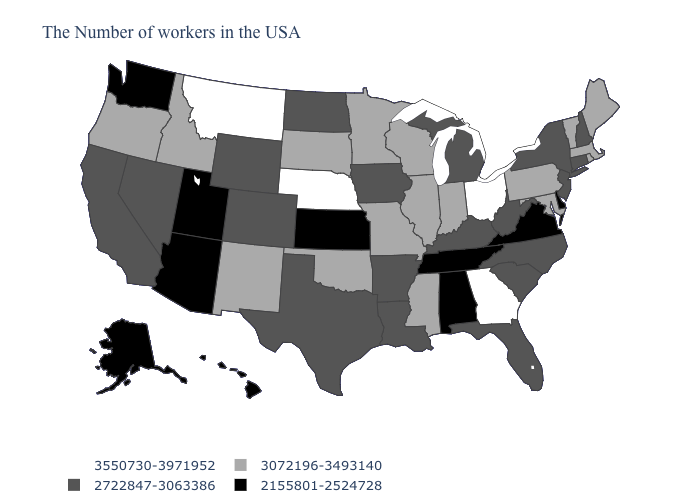What is the value of West Virginia?
Give a very brief answer. 2722847-3063386. What is the highest value in the USA?
Answer briefly. 3550730-3971952. Does Florida have a higher value than Kansas?
Quick response, please. Yes. Does Oregon have a higher value than West Virginia?
Short answer required. Yes. How many symbols are there in the legend?
Write a very short answer. 4. Among the states that border Florida , does Alabama have the highest value?
Write a very short answer. No. What is the highest value in states that border Minnesota?
Concise answer only. 3072196-3493140. What is the highest value in the MidWest ?
Quick response, please. 3550730-3971952. Does Pennsylvania have the same value as Maine?
Quick response, please. Yes. Does the first symbol in the legend represent the smallest category?
Answer briefly. No. Among the states that border Montana , which have the lowest value?
Write a very short answer. North Dakota, Wyoming. Which states have the lowest value in the West?
Be succinct. Utah, Arizona, Washington, Alaska, Hawaii. Which states hav the highest value in the Northeast?
Quick response, please. Maine, Massachusetts, Rhode Island, Vermont, Pennsylvania. Among the states that border Ohio , does Kentucky have the lowest value?
Give a very brief answer. Yes. What is the value of Missouri?
Give a very brief answer. 3072196-3493140. 